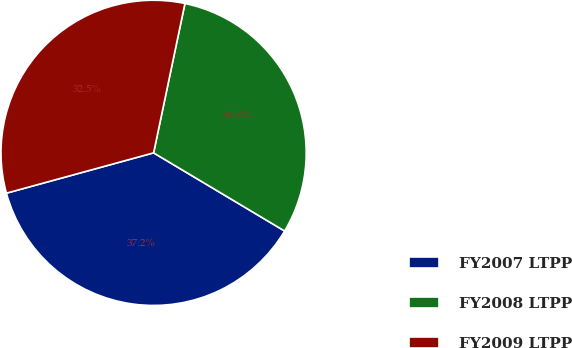Convert chart. <chart><loc_0><loc_0><loc_500><loc_500><pie_chart><fcel>FY2007 LTPP<fcel>FY2008 LTPP<fcel>FY2009 LTPP<nl><fcel>37.18%<fcel>30.27%<fcel>32.55%<nl></chart> 